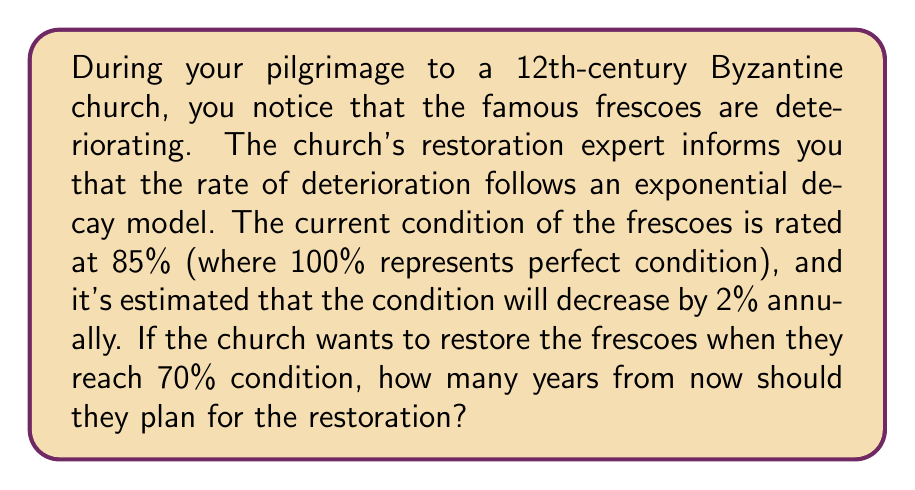Give your solution to this math problem. To solve this problem, we'll use the exponential decay formula:

$$A(t) = A_0 \cdot (1-r)^t$$

Where:
$A(t)$ is the amount at time $t$
$A_0$ is the initial amount
$r$ is the decay rate (as a decimal)
$t$ is the time

Given:
- Initial condition $(A_0)$: 85%
- Decay rate $(r)$: 2% = 0.02
- Target condition $(A(t))$: 70%

We need to solve for $t$.

Step 1: Set up the equation
$$70 = 85 \cdot (1-0.02)^t$$

Step 2: Divide both sides by 85
$$\frac{70}{85} = (1-0.02)^t$$

Step 3: Take the natural logarithm of both sides
$$\ln(\frac{70}{85}) = t \cdot \ln(1-0.02)$$

Step 4: Solve for $t$
$$t = \frac{\ln(\frac{70}{85})}{\ln(1-0.02)}$$

Step 5: Calculate the result
$$t = \frac{\ln(0.8235)}{\ln(0.98)} \approx 9.7233$$

Since we can only plan in whole years, we round up to the nearest integer.
Answer: The church should plan for restoration in 10 years. 